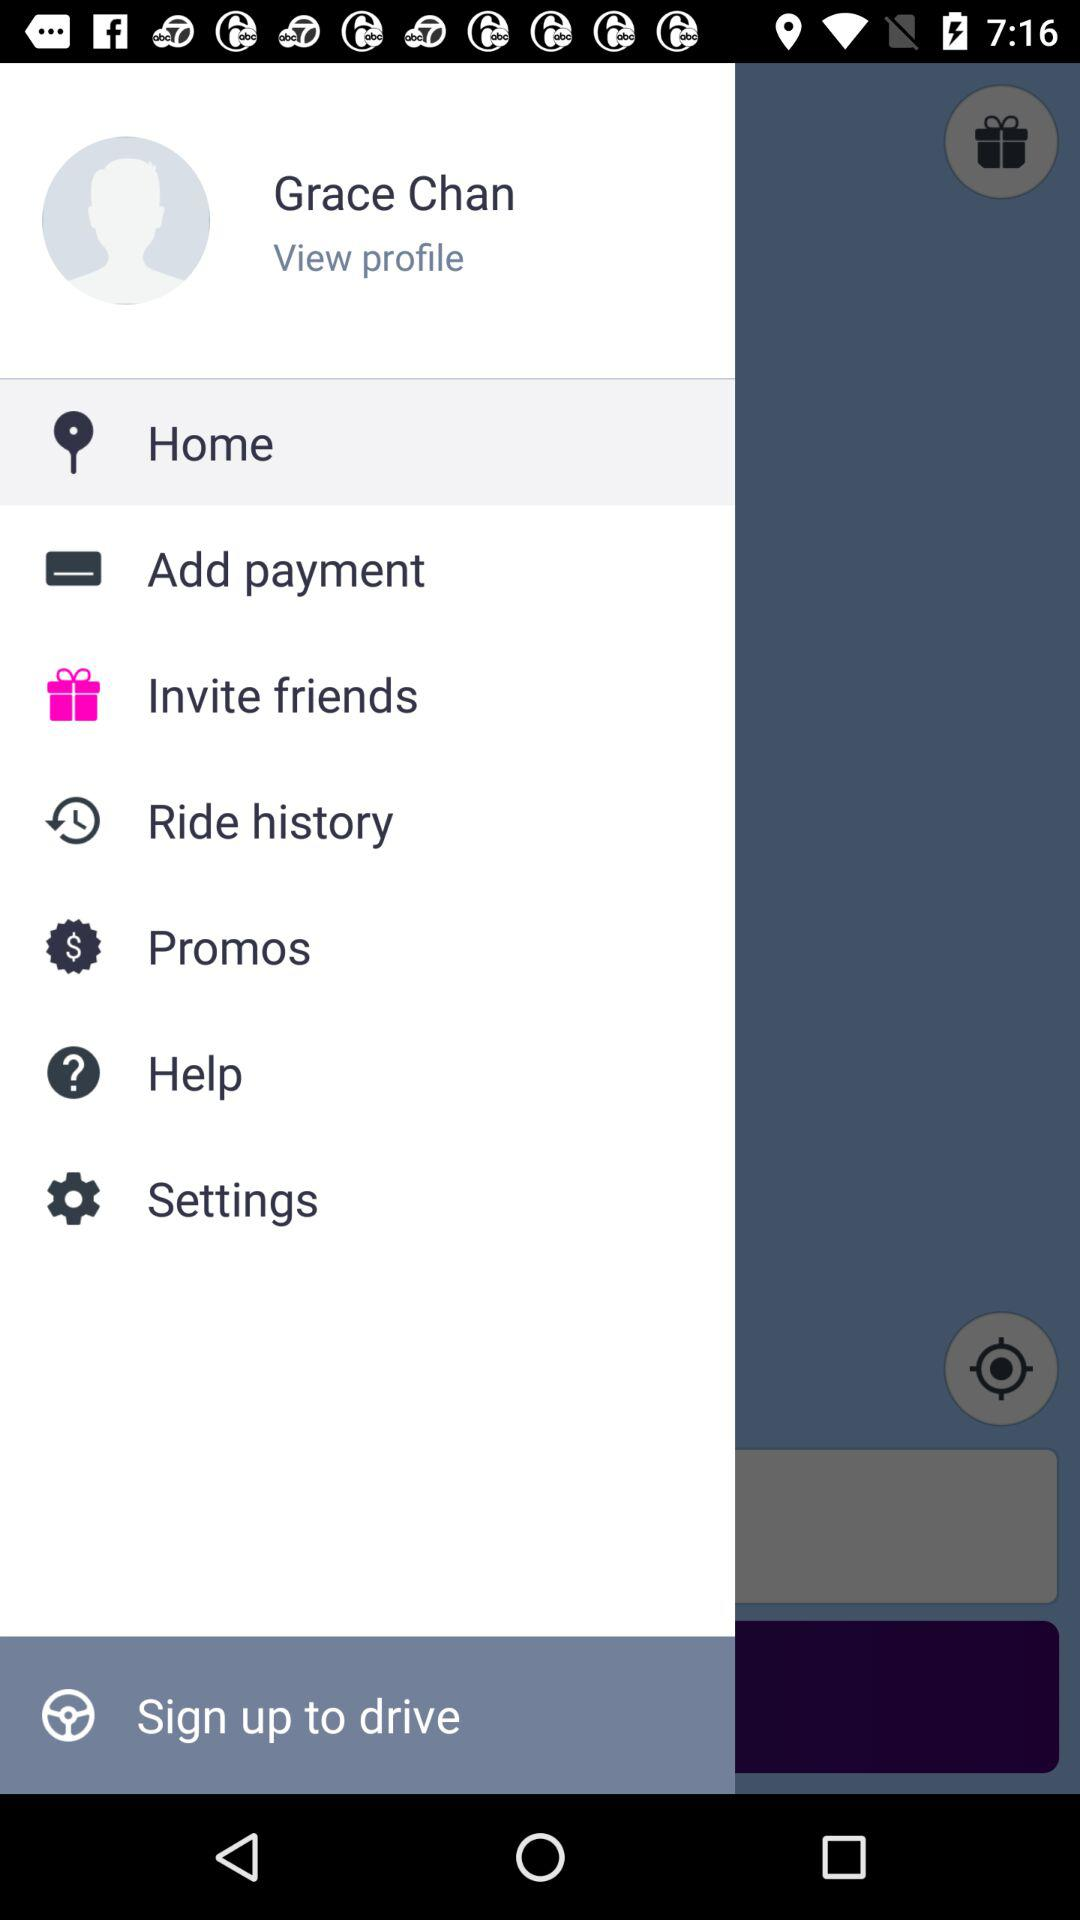What is the login name? The login name is Grace Chan. 